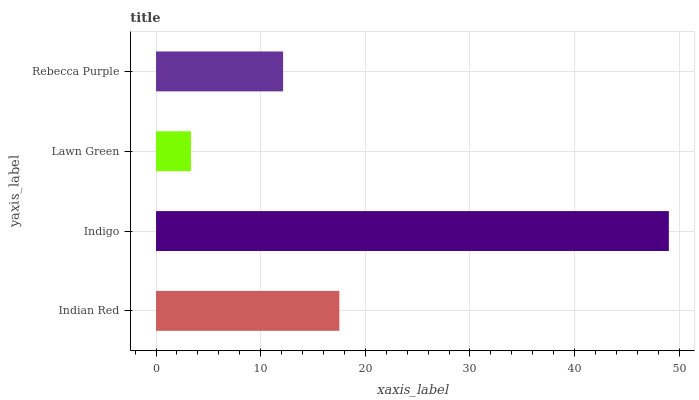Is Lawn Green the minimum?
Answer yes or no. Yes. Is Indigo the maximum?
Answer yes or no. Yes. Is Indigo the minimum?
Answer yes or no. No. Is Lawn Green the maximum?
Answer yes or no. No. Is Indigo greater than Lawn Green?
Answer yes or no. Yes. Is Lawn Green less than Indigo?
Answer yes or no. Yes. Is Lawn Green greater than Indigo?
Answer yes or no. No. Is Indigo less than Lawn Green?
Answer yes or no. No. Is Indian Red the high median?
Answer yes or no. Yes. Is Rebecca Purple the low median?
Answer yes or no. Yes. Is Lawn Green the high median?
Answer yes or no. No. Is Indian Red the low median?
Answer yes or no. No. 